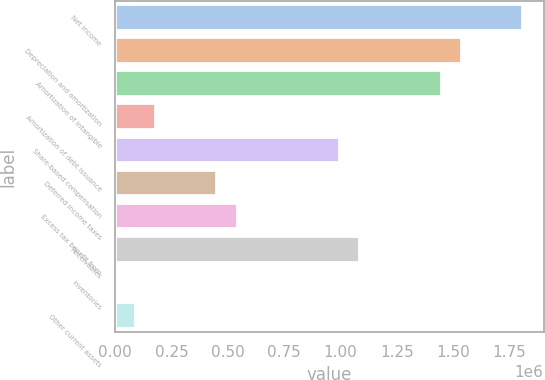Convert chart. <chart><loc_0><loc_0><loc_500><loc_500><bar_chart><fcel>Net income<fcel>Depreciation and amortization<fcel>Amortization of intangible<fcel>Amortization of debt issuance<fcel>Share-based compensation<fcel>Deferred income taxes<fcel>Excess tax benefit from<fcel>Receivables<fcel>Inventories<fcel>Other current assets<nl><fcel>1.81162e+06<fcel>1.53997e+06<fcel>1.44942e+06<fcel>181709<fcel>996666<fcel>453361<fcel>543912<fcel>1.08722e+06<fcel>607<fcel>91157.8<nl></chart> 